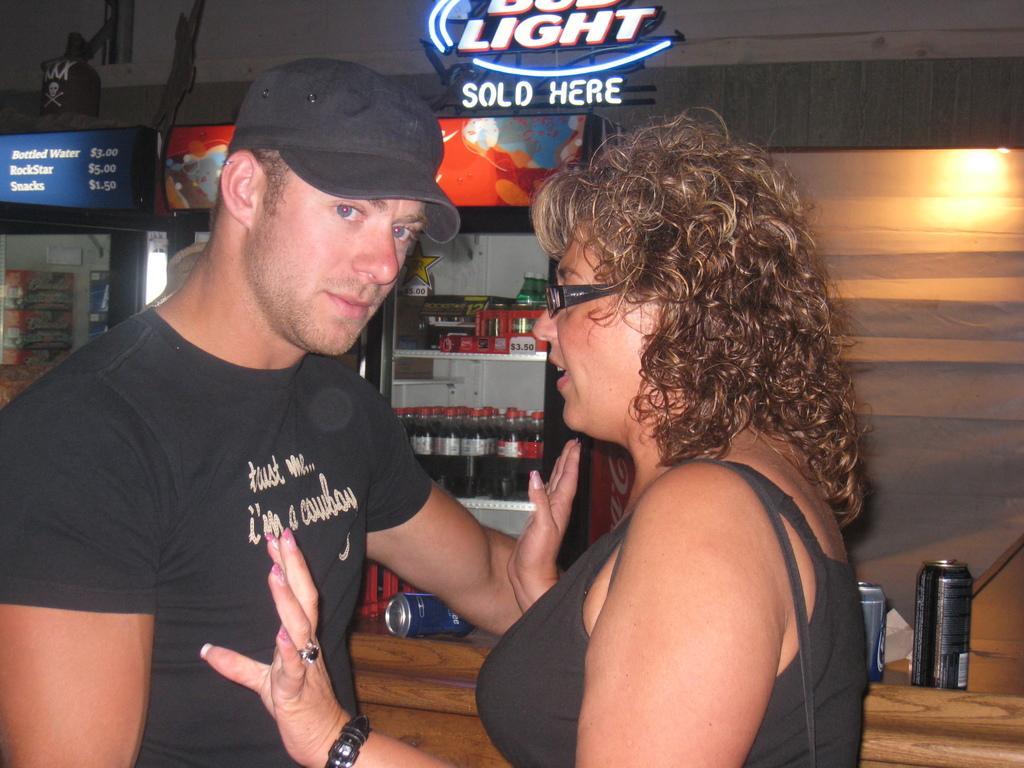Describe this image in one or two sentences. In the front of the image I can see two people. A person wore a cap. In the background of the image there are fridges, table, tennis, boards, lights, bottles, box, wall, stickers and objects. Something is written on a board. 